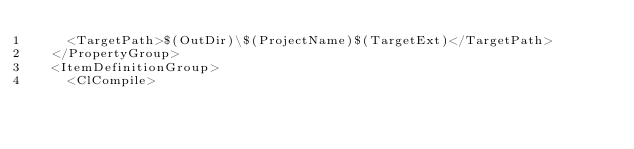Convert code to text. <code><loc_0><loc_0><loc_500><loc_500><_XML_>    <TargetPath>$(OutDir)\$(ProjectName)$(TargetExt)</TargetPath>
  </PropertyGroup>
  <ItemDefinitionGroup>
    <ClCompile></code> 